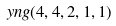Convert formula to latex. <formula><loc_0><loc_0><loc_500><loc_500>\ y n g ( 4 , 4 , 2 , 1 , 1 )</formula> 